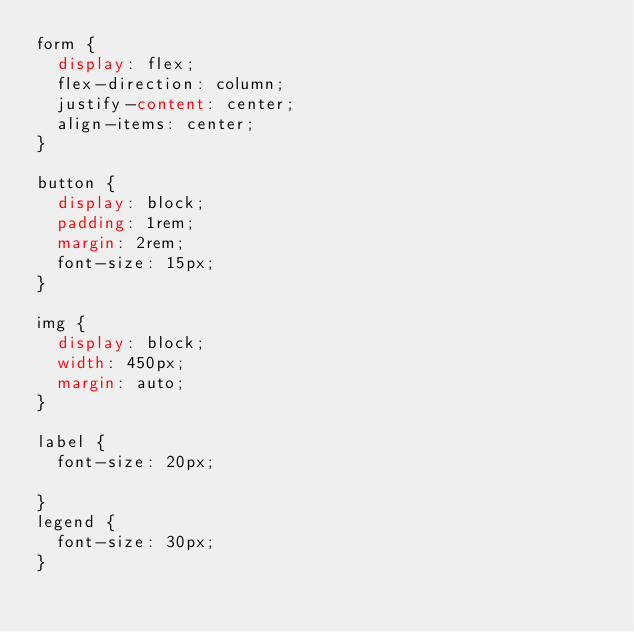Convert code to text. <code><loc_0><loc_0><loc_500><loc_500><_CSS_>form {
  display: flex;
  flex-direction: column;
  justify-content: center;
  align-items: center;
}

button {
  display: block;
  padding: 1rem;
  margin: 2rem;
  font-size: 15px;
}

img {
  display: block;
  width: 450px;
  margin: auto;
}

label {
  font-size: 20px;

}
legend {
  font-size: 30px;
}</code> 